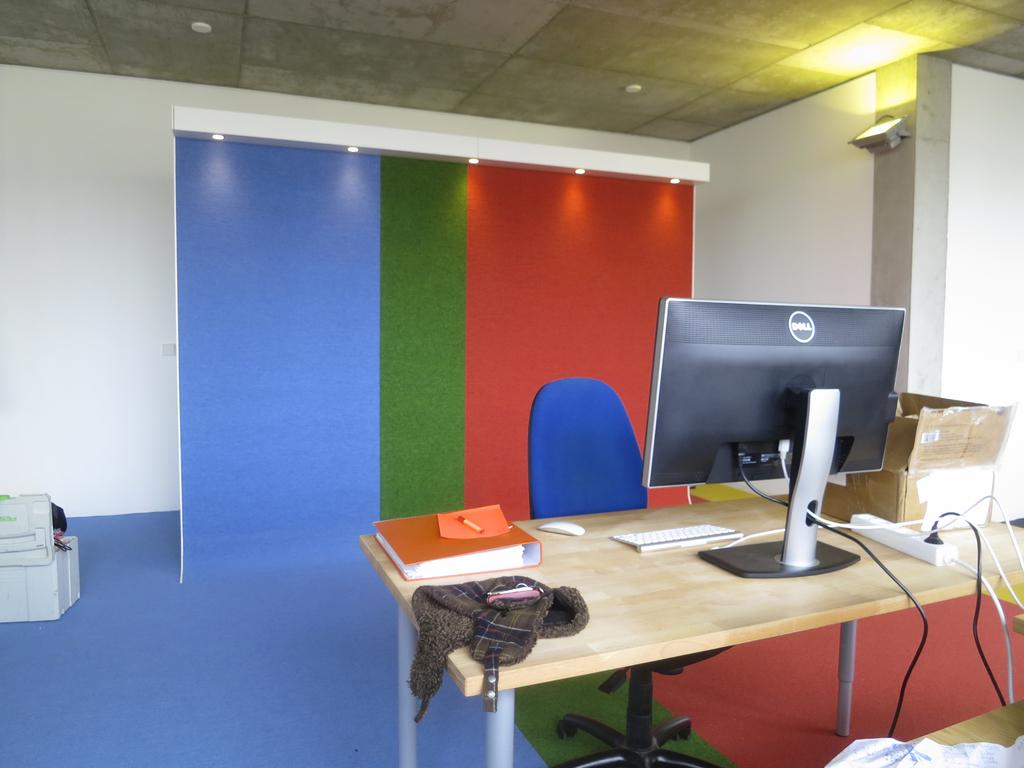<image>
Summarize the visual content of the image. A dell computer monitor is on a desk. 